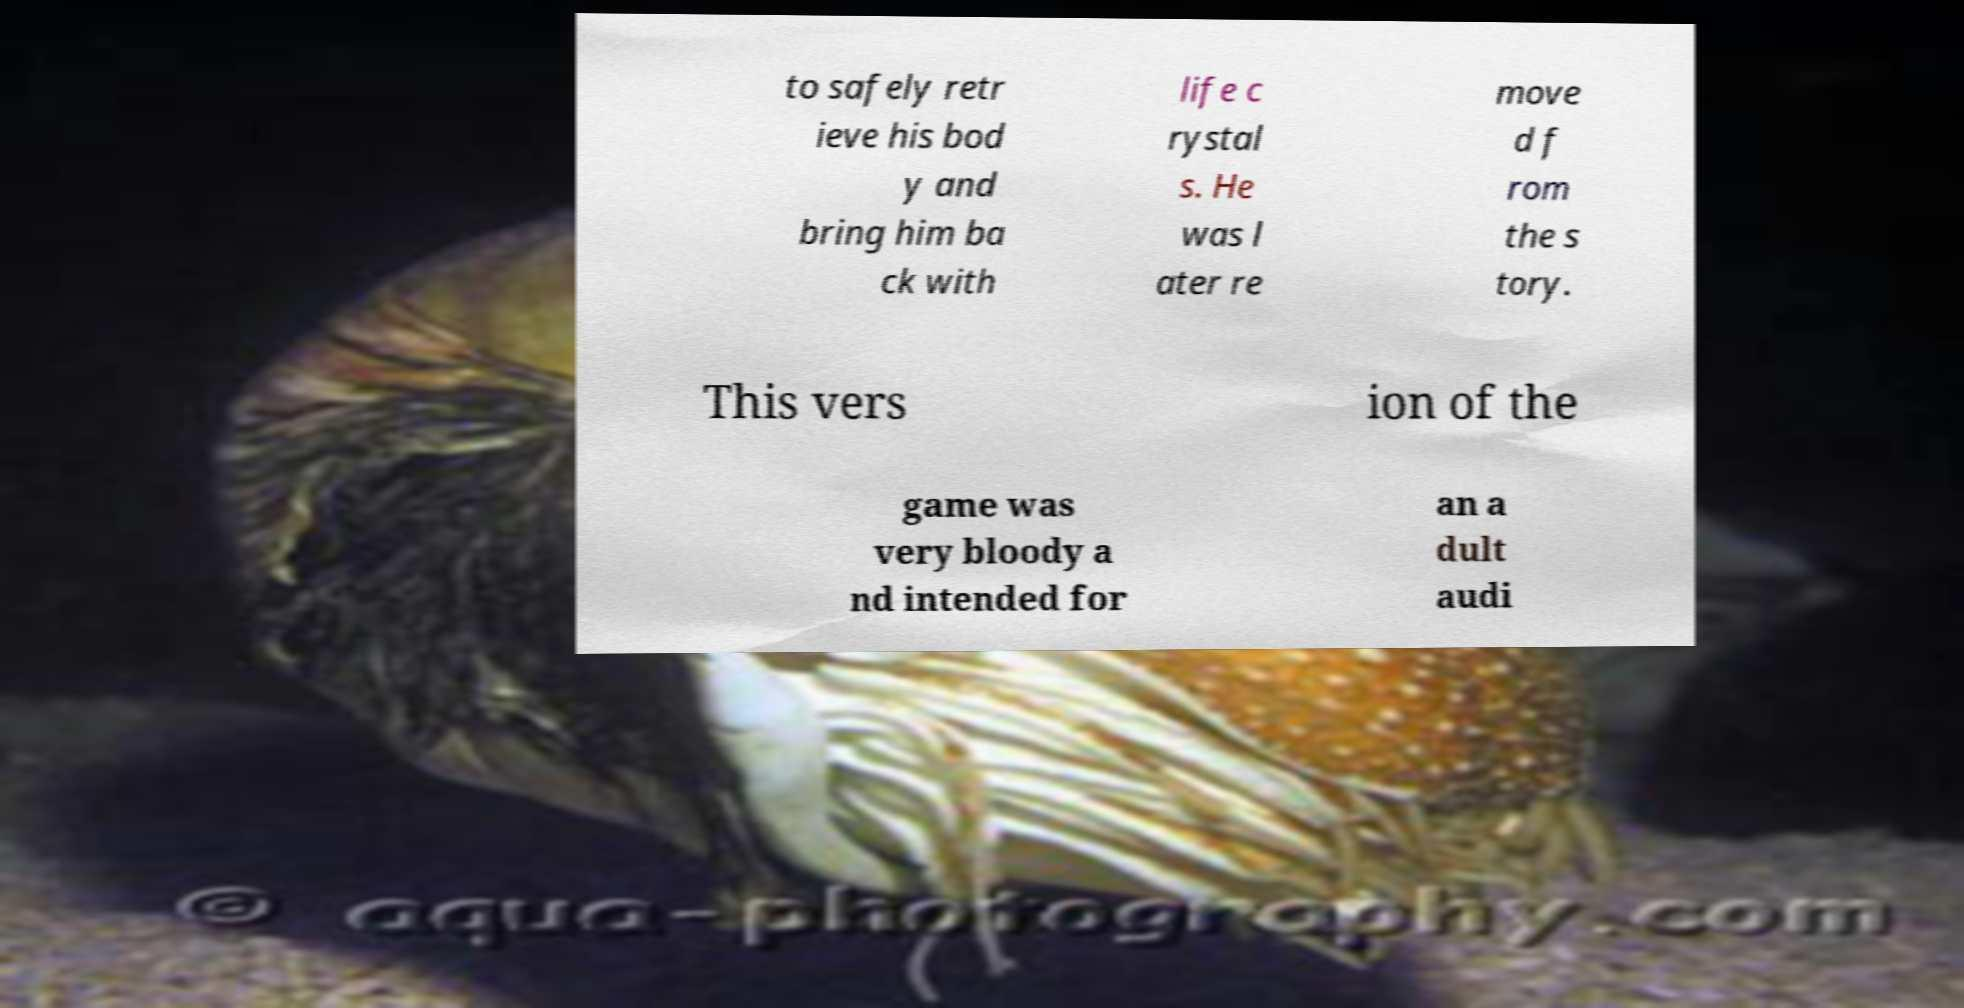Please identify and transcribe the text found in this image. to safely retr ieve his bod y and bring him ba ck with life c rystal s. He was l ater re move d f rom the s tory. This vers ion of the game was very bloody a nd intended for an a dult audi 